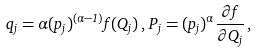Convert formula to latex. <formula><loc_0><loc_0><loc_500><loc_500>q _ { j } = \alpha ( { p _ { j } } ) ^ { ( \alpha - 1 ) } f ( Q _ { j } ) \, , \, P _ { j } = ( { p _ { j } } ) ^ { \alpha } \frac { \partial f } { \partial Q _ { j } } \, ,</formula> 